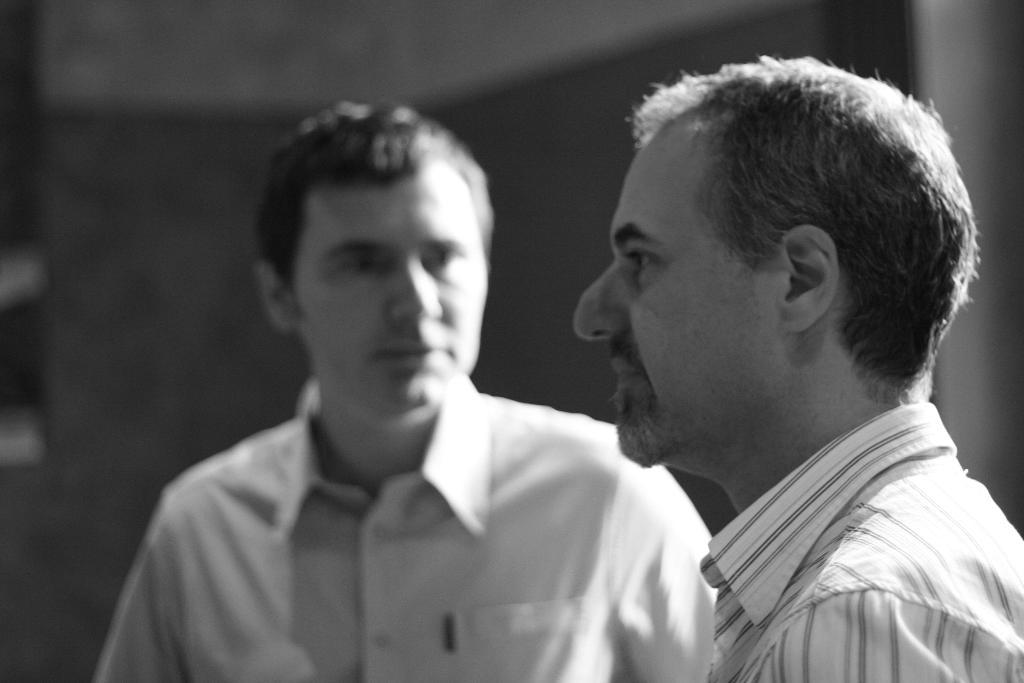What is the color scheme of the image? The image is black and white. Can you describe the people in the image? There is a person standing in the foreground and another person standing in the center of the image. What can be observed about the background of the image? The background of the image is blurred. What type of brush is being used by the person in the image? There is no brush present in the image. What kind of punishment is being administered to the person in the image? There is no punishment being administered in the image; it only shows two people standing in different positions. 